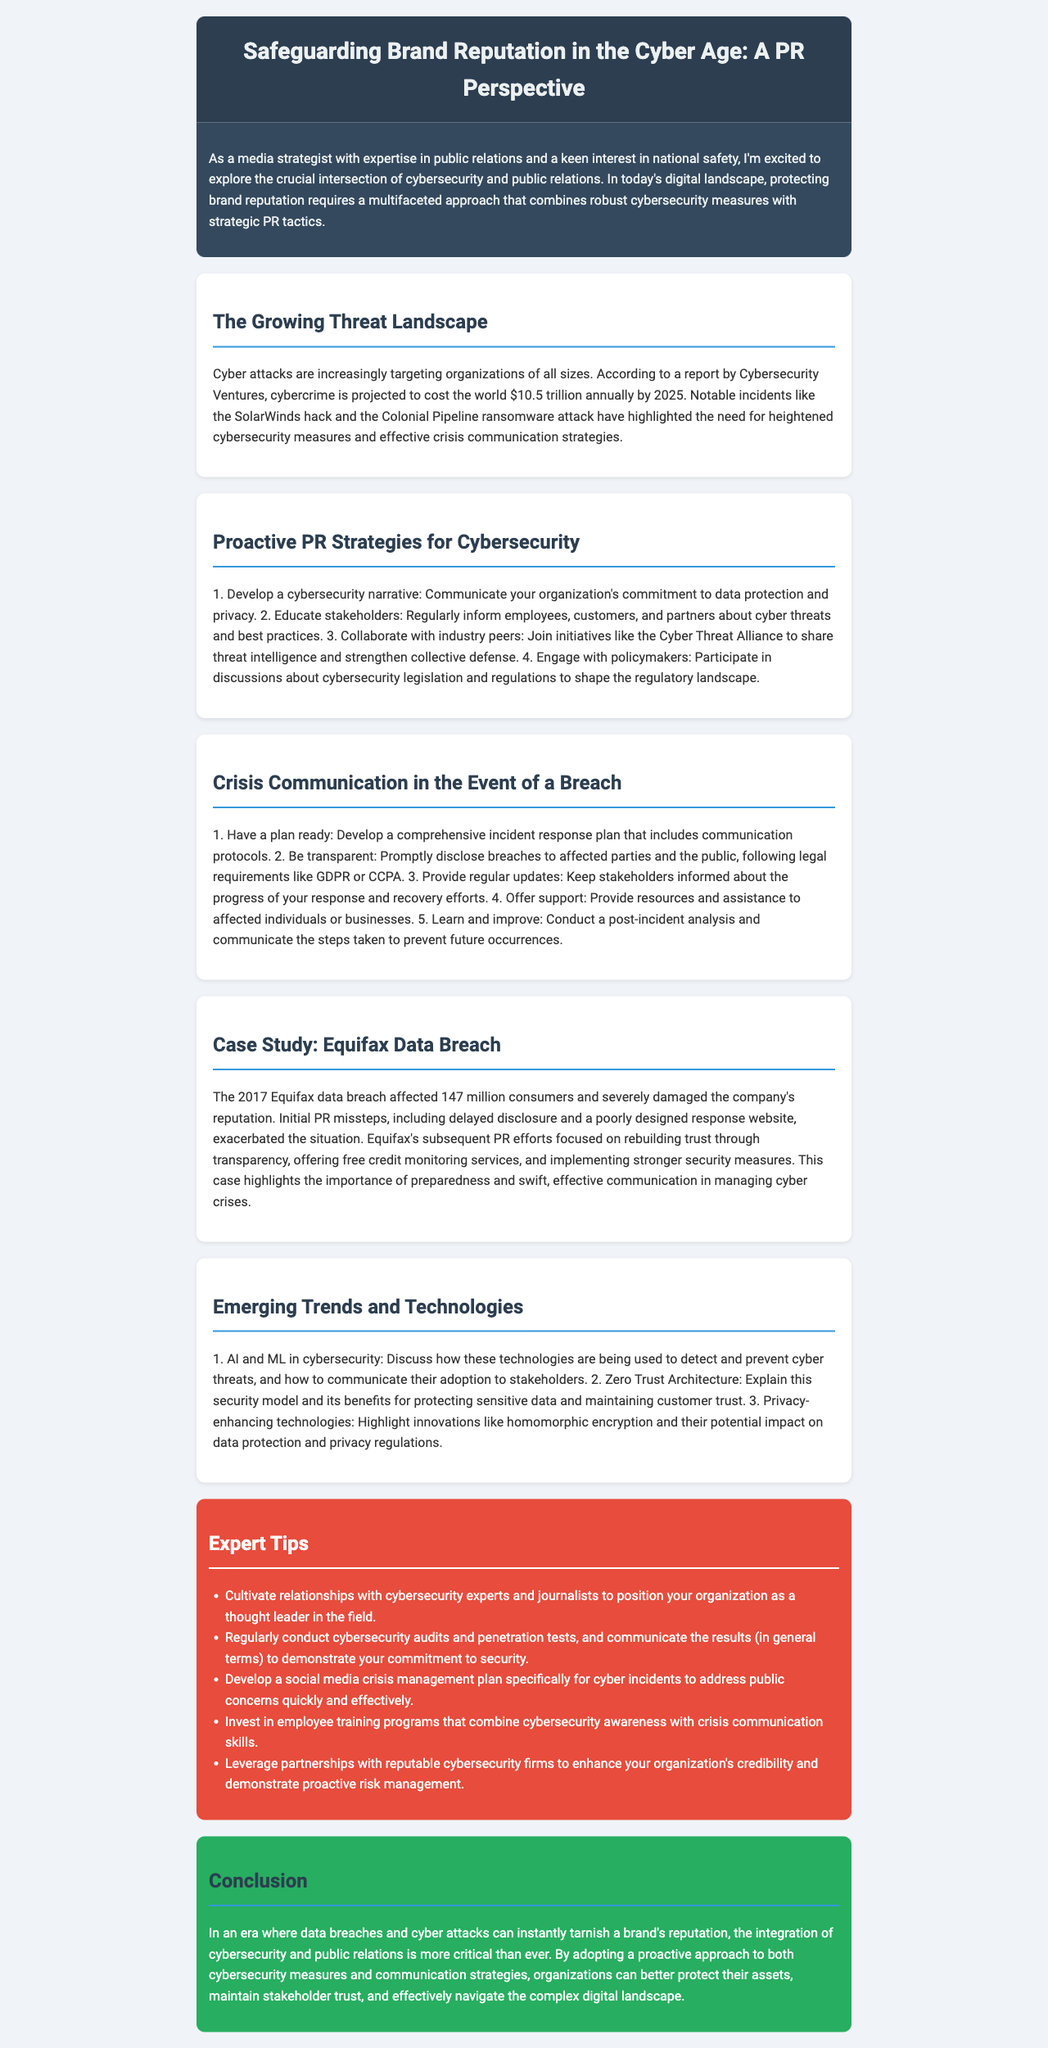what is the projected cost of cybercrime by 2025? According to Cybersecurity Ventures, the projected cost is $10.5 trillion annually by 2025.
Answer: $10.5 trillion what percentage of consumers were affected by the Equifax data breach? The Equifax data breach affected 147 million consumers.
Answer: 147 million what is the first tip for proactive PR strategies in cybersecurity? The first tip is to develop a cybersecurity narrative.
Answer: develop a cybersecurity narrative what legislation must organizations comply with when disclosing breaches? Organizations must follow legal requirements like GDPR or CCPA when disclosing breaches.
Answer: GDPR or CCPA what is one emerging technology in cybersecurity mentioned in the document? The document mentions AI and ML in cybersecurity as an emerging technology.
Answer: AI and ML how can organizations demonstrate their commitment to security? Organizations can conduct cybersecurity audits and penetration tests and communicate the results to stakeholders.
Answer: cybersecurity audits and penetration tests what should a crisis communication plan include? A crisis communication plan should include comprehensive incident response protocols.
Answer: incident response protocols which case study is highlighted in the document? The highlighted case study in the document is the Equifax data breach.
Answer: Equifax data breach what is the color of the expert tips section? The expert tips section is colored red.
Answer: red 